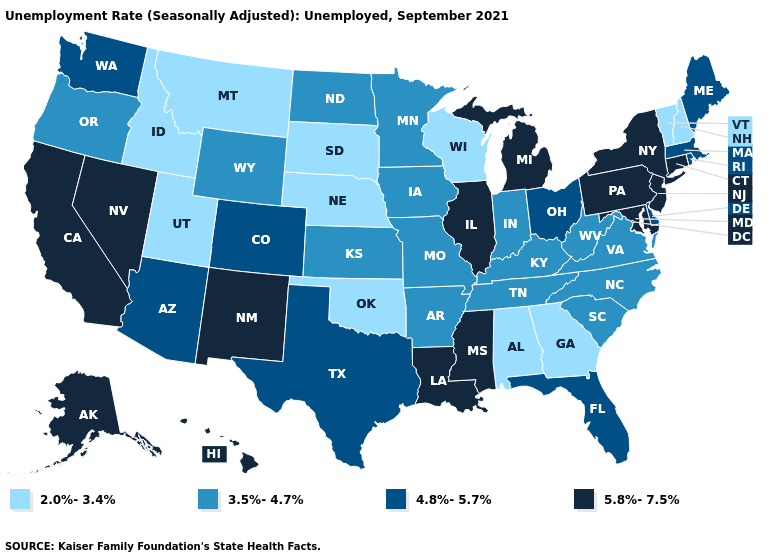What is the lowest value in the USA?
Quick response, please. 2.0%-3.4%. Name the states that have a value in the range 3.5%-4.7%?
Give a very brief answer. Arkansas, Indiana, Iowa, Kansas, Kentucky, Minnesota, Missouri, North Carolina, North Dakota, Oregon, South Carolina, Tennessee, Virginia, West Virginia, Wyoming. Name the states that have a value in the range 4.8%-5.7%?
Give a very brief answer. Arizona, Colorado, Delaware, Florida, Maine, Massachusetts, Ohio, Rhode Island, Texas, Washington. Name the states that have a value in the range 5.8%-7.5%?
Keep it brief. Alaska, California, Connecticut, Hawaii, Illinois, Louisiana, Maryland, Michigan, Mississippi, Nevada, New Jersey, New Mexico, New York, Pennsylvania. Does Ohio have the lowest value in the MidWest?
Short answer required. No. What is the value of Virginia?
Quick response, please. 3.5%-4.7%. Name the states that have a value in the range 2.0%-3.4%?
Short answer required. Alabama, Georgia, Idaho, Montana, Nebraska, New Hampshire, Oklahoma, South Dakota, Utah, Vermont, Wisconsin. Among the states that border Wisconsin , does Illinois have the highest value?
Give a very brief answer. Yes. Which states have the lowest value in the USA?
Give a very brief answer. Alabama, Georgia, Idaho, Montana, Nebraska, New Hampshire, Oklahoma, South Dakota, Utah, Vermont, Wisconsin. Does Mississippi have a higher value than Rhode Island?
Keep it brief. Yes. Name the states that have a value in the range 5.8%-7.5%?
Be succinct. Alaska, California, Connecticut, Hawaii, Illinois, Louisiana, Maryland, Michigan, Mississippi, Nevada, New Jersey, New Mexico, New York, Pennsylvania. What is the value of Mississippi?
Give a very brief answer. 5.8%-7.5%. Which states hav the highest value in the Northeast?
Short answer required. Connecticut, New Jersey, New York, Pennsylvania. What is the value of Indiana?
Be succinct. 3.5%-4.7%. Is the legend a continuous bar?
Be succinct. No. 